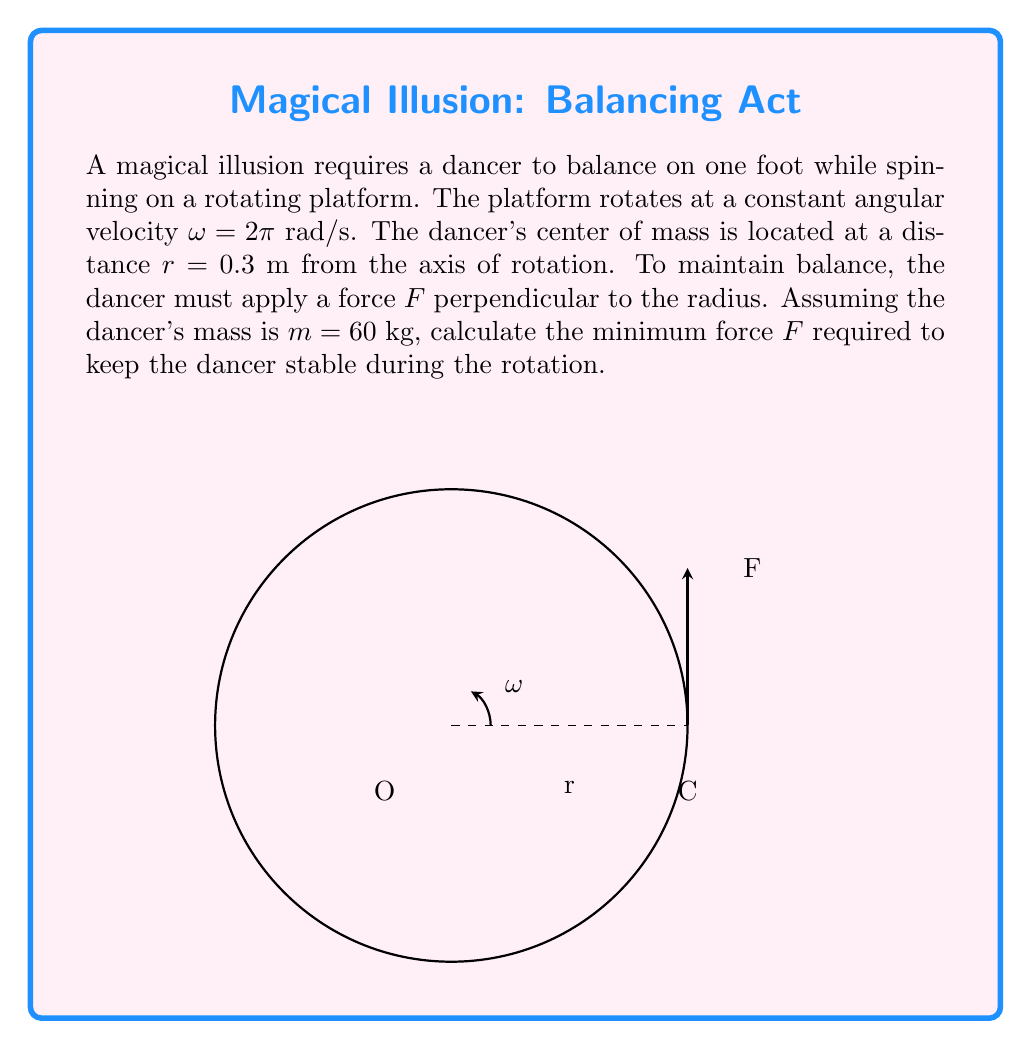Show me your answer to this math problem. To solve this problem, we'll use the concept of centripetal force in circular motion. The steps are as follows:

1) In circular motion, the centripetal force $F_c$ is given by:

   $$F_c = m\omega^2r$$

   where $m$ is the mass, $\omega$ is the angular velocity, and $r$ is the radius of rotation.

2) We're given:
   $m = 60$ kg
   $\omega = 2\pi$ rad/s
   $r = 0.3$ m

3) Substitute these values into the equation:

   $$F_c = 60 \cdot (2\pi)^2 \cdot 0.3$$

4) Simplify:
   $$F_c = 60 \cdot 4\pi^2 \cdot 0.3 = 72\pi^2$$

5) Calculate the final value:
   $$F_c \approx 710.73 \text{ N}$$

6) The force $F$ that the dancer needs to apply must be equal to this centripetal force to maintain stability during the rotation.

Therefore, the minimum force $F$ required is approximately 710.73 N.
Answer: $710.73 \text{ N}$ 